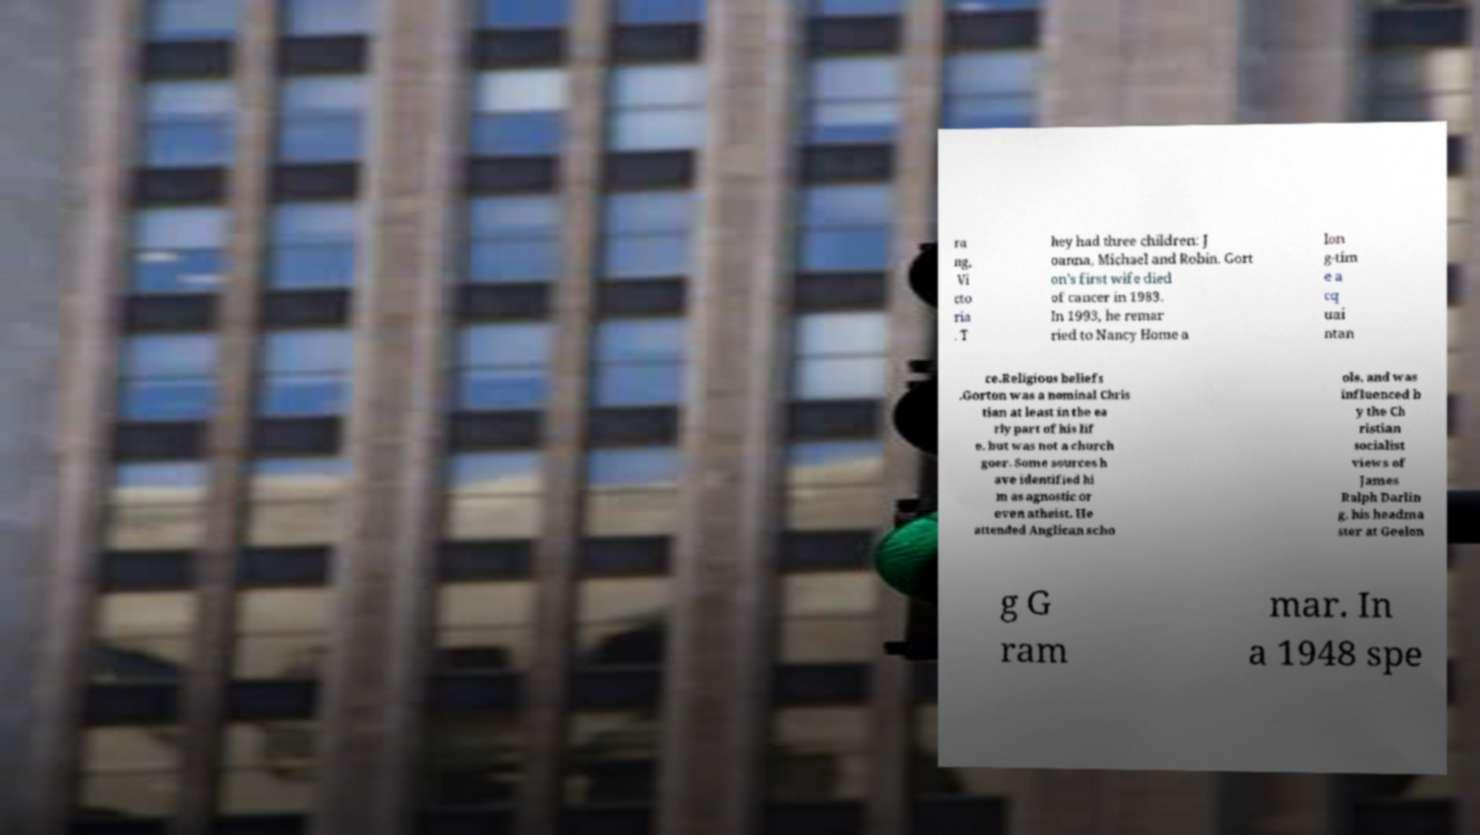Can you read and provide the text displayed in the image?This photo seems to have some interesting text. Can you extract and type it out for me? ra ng, Vi cto ria . T hey had three children: J oanna, Michael and Robin. Gort on's first wife died of cancer in 1983. In 1993, he remar ried to Nancy Home a lon g-tim e a cq uai ntan ce.Religious beliefs .Gorton was a nominal Chris tian at least in the ea rly part of his lif e, but was not a church goer. Some sources h ave identified hi m as agnostic or even atheist. He attended Anglican scho ols, and was influenced b y the Ch ristian socialist views of James Ralph Darlin g, his headma ster at Geelon g G ram mar. In a 1948 spe 